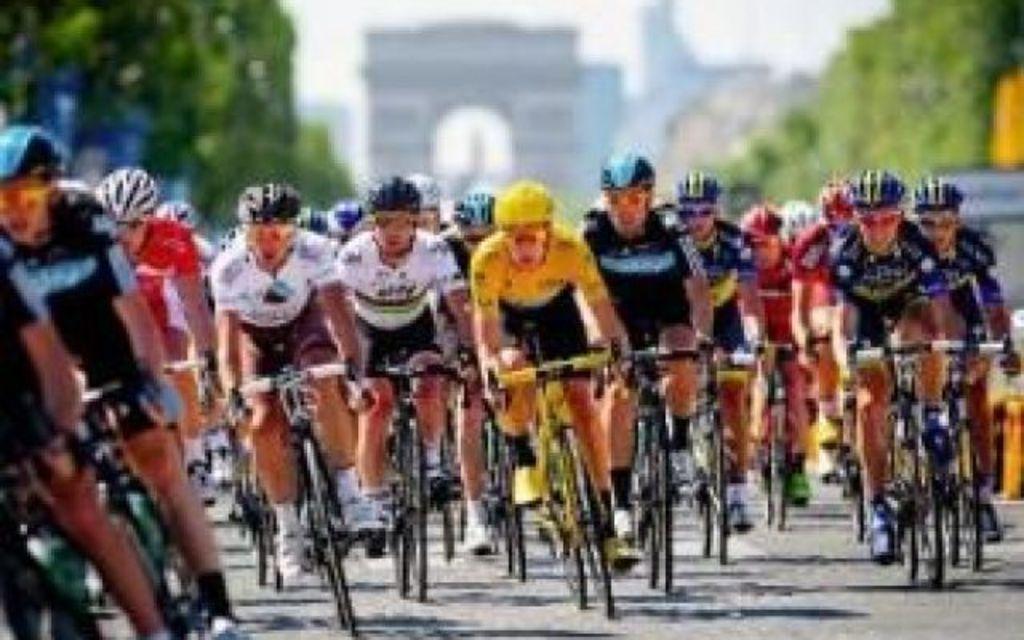In one or two sentences, can you explain what this image depicts? In this image we can see people are riding bicycles on the road. There is a blur background and we can see an arch, trees, and sky. 